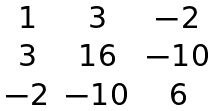Convert formula to latex. <formula><loc_0><loc_0><loc_500><loc_500>\begin{matrix} 1 & 3 & - 2 \\ 3 & 1 6 & - 1 0 \\ - 2 & - 1 0 & 6 \end{matrix}</formula> 